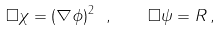<formula> <loc_0><loc_0><loc_500><loc_500>\Box \chi = ( \nabla \phi ) ^ { 2 } \ , \quad \Box \psi = R \, ,</formula> 